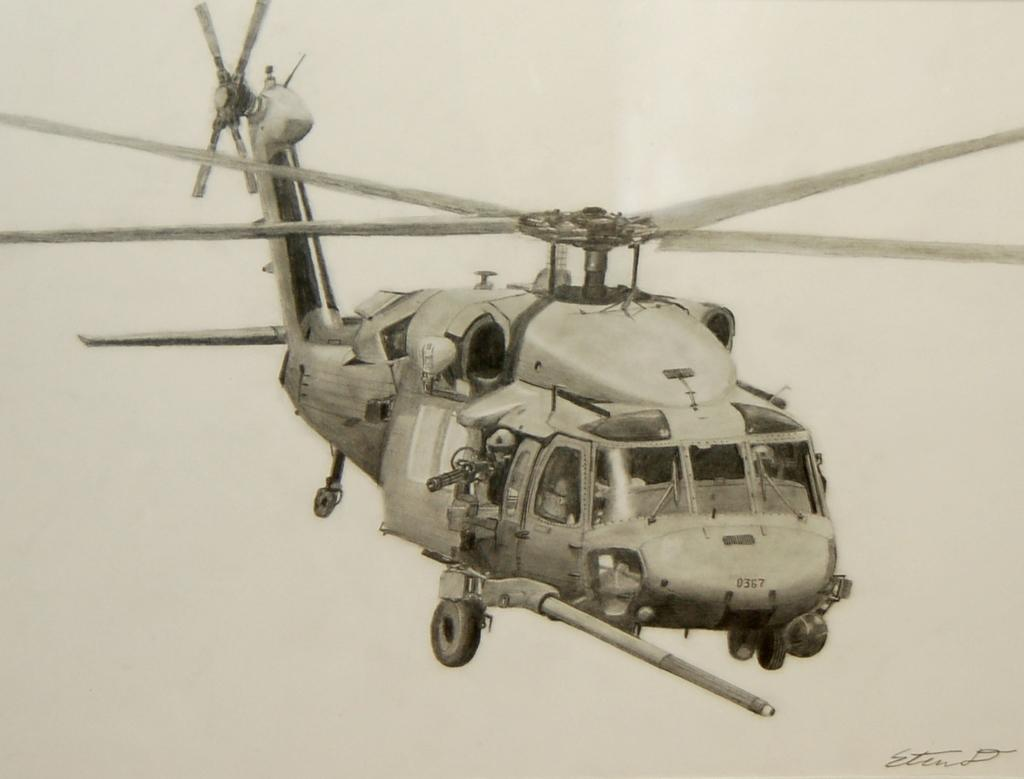What is the main subject of the image? The main subject of the image is a helicopter. Are there any specific details about the helicopter in the image? No specific details about the helicopter are mentioned in the provided facts. What else can be seen in the image besides the helicopter? There are numbers written in the image. What is the color scheme of the image? The image is black and white in color. Can you tell me how many icicles are hanging from the helicopter in the image? There are no icicles present in the image; it features a helicopter and numbers in a black and white color scheme. 